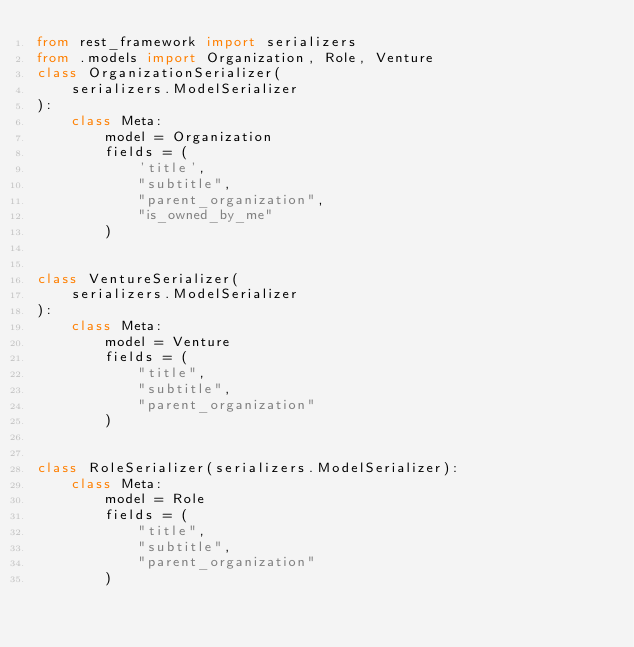<code> <loc_0><loc_0><loc_500><loc_500><_Python_>from rest_framework import serializers
from .models import Organization, Role, Venture
class OrganizationSerializer(
    serializers.ModelSerializer
):
    class Meta:
        model = Organization
        fields = (
            'title',
            "subtitle",
            "parent_organization",
            "is_owned_by_me"
        )


class VentureSerializer(
    serializers.ModelSerializer
):
    class Meta:
        model = Venture
        fields = (
            "title",
            "subtitle",
            "parent_organization"
        )


class RoleSerializer(serializers.ModelSerializer):
    class Meta:
        model = Role
        fields = (
            "title",
            "subtitle",
            "parent_organization"
        )

</code> 